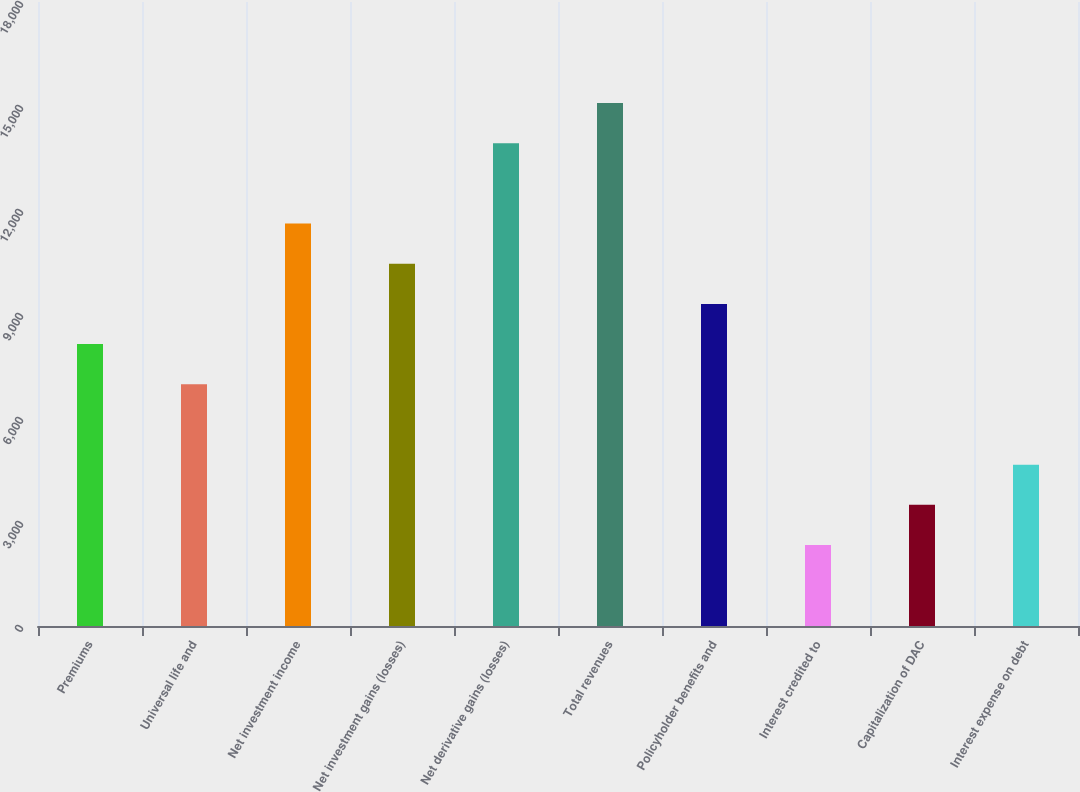<chart> <loc_0><loc_0><loc_500><loc_500><bar_chart><fcel>Premiums<fcel>Universal life and<fcel>Net investment income<fcel>Net investment gains (losses)<fcel>Net derivative gains (losses)<fcel>Total revenues<fcel>Policyholder benefits and<fcel>Interest credited to<fcel>Capitalization of DAC<fcel>Interest expense on debt<nl><fcel>8131.3<fcel>6972.4<fcel>11608<fcel>10449.1<fcel>13925.8<fcel>15084.7<fcel>9290.2<fcel>2336.8<fcel>3495.7<fcel>4654.6<nl></chart> 